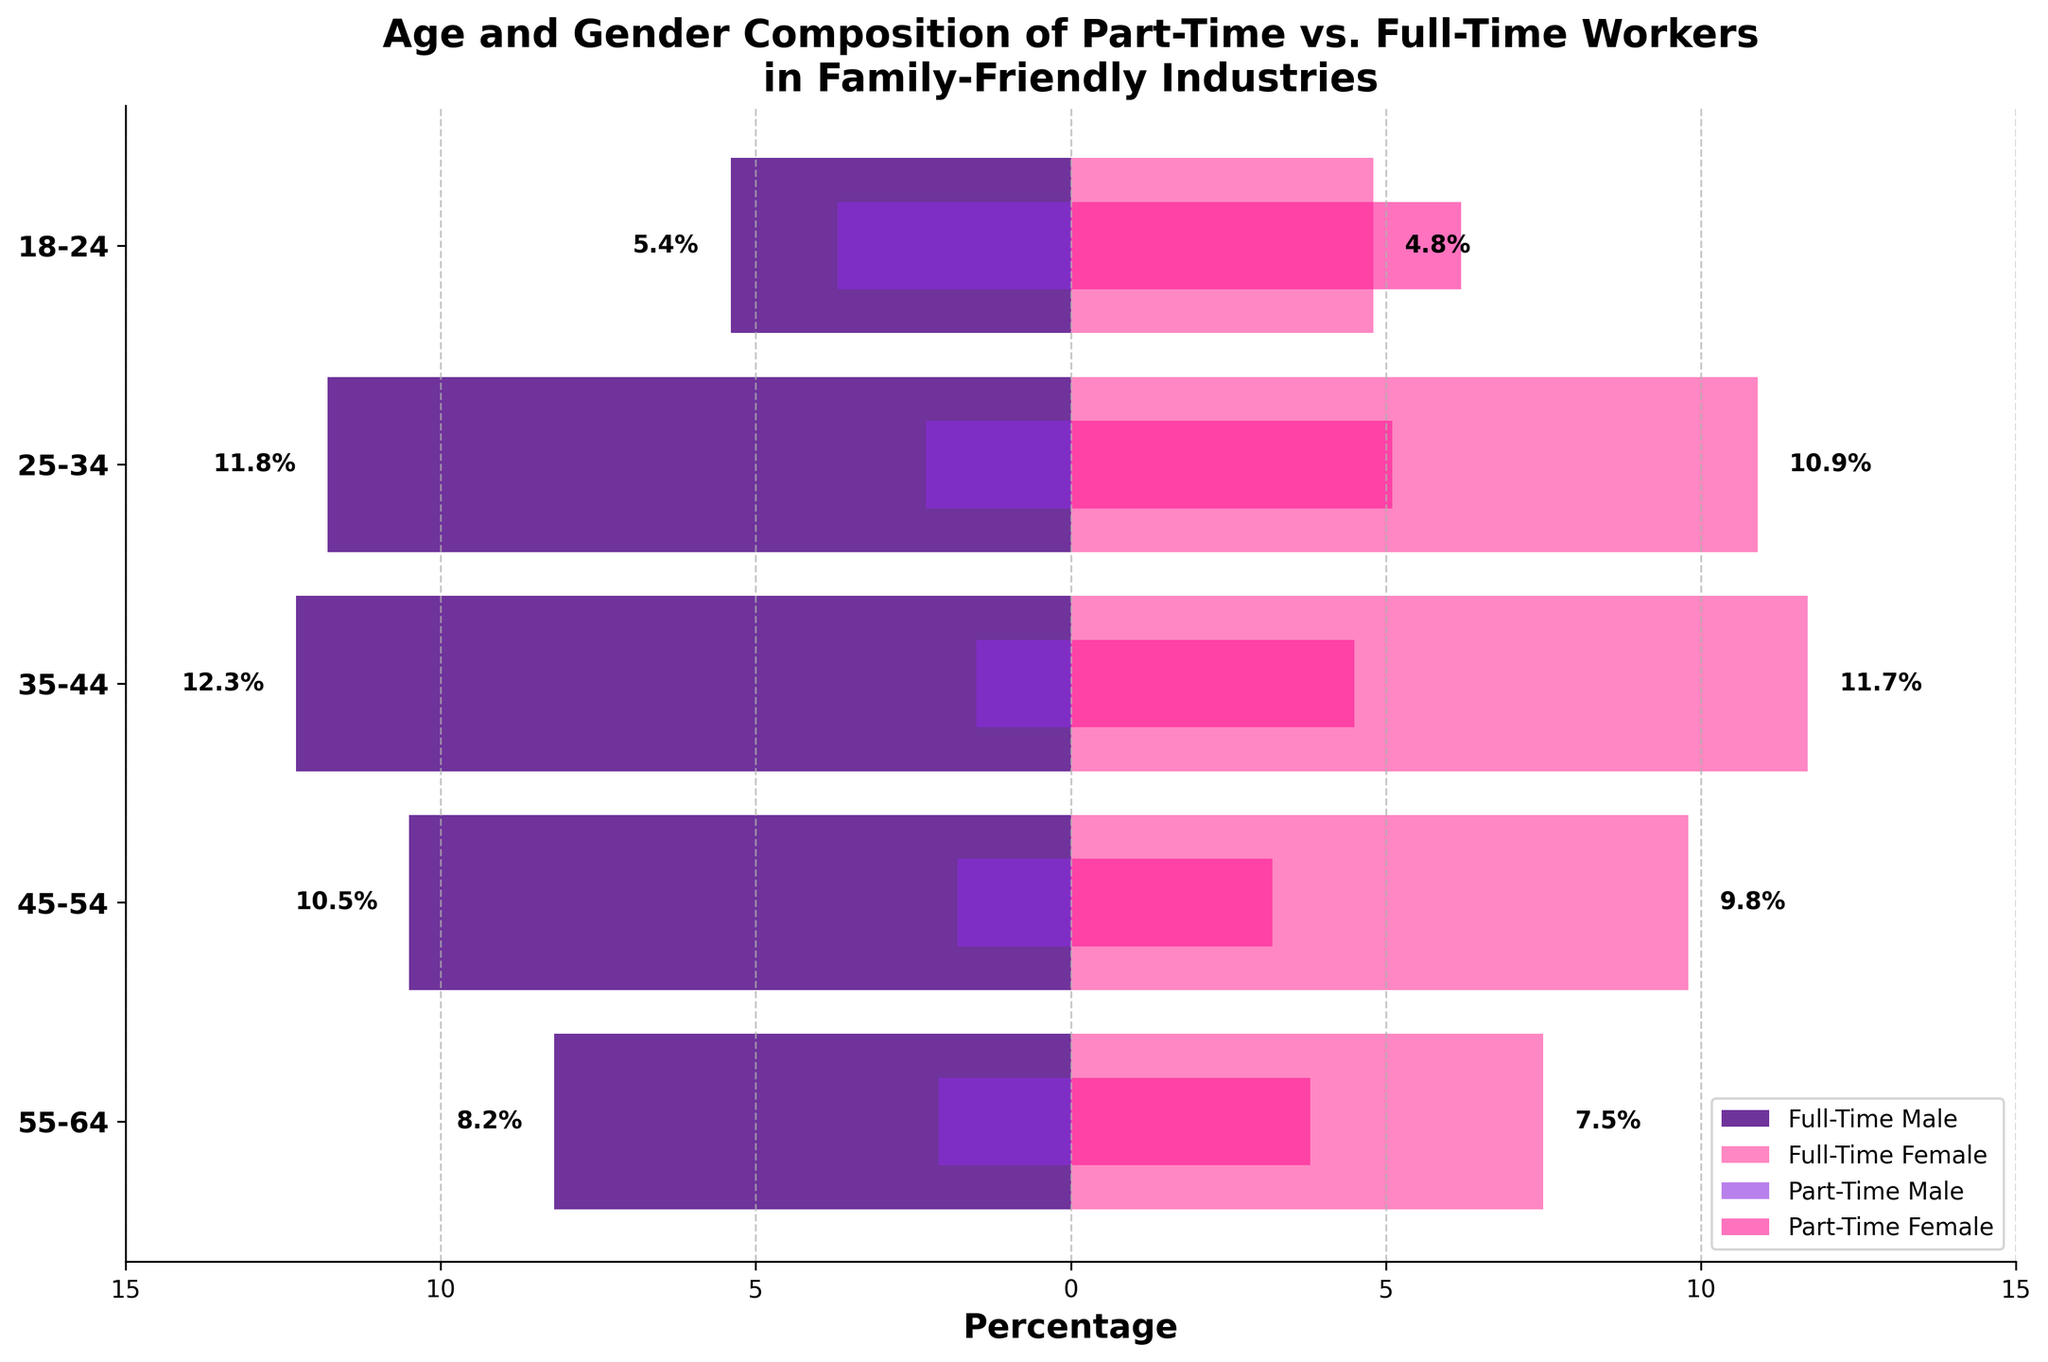What is the title of the figure? The title is located at the top of the figure. It provides a brief description of what the figure represents.
Answer: Age and Gender Composition of Part-Time vs. Full-Time Workers in Family-Friendly Industries Which age group has the highest percentage of full-time male workers? To determine this, look for the longest bar on the negative side of the x-axis within the 'Full-Time Male' section, then refer to the corresponding age group on the y-axis.
Answer: 35-44 In the age group 25-34, which gender has more part-time workers? Compare the lengths of the bars for 'Part-Time Male' and 'Part-Time Female' within the 25-34 age group. The longer bar represents the gender with more part-time workers.
Answer: Female How does the percentage of part-time female workers in the 18-24 age group compare to full-time male workers in the same age group? Look at the lengths of the bars for 'Part-Time Female' and 'Full-Time Male' within the 18-24 age group. The 'Part-Time Female' bar is longer.
Answer: Part-time female workers have a higher percentage What is the sum of full-time male and female workers in the 45-54 age group? Add the percentages from the 'Full-Time Male' and 'Full-Time Female' bars within the 45-54 age group. 10.5% (male) + 9.8% (female) = 20.3%.
Answer: 20.3% What is the percentage difference between part-time male and female workers in the 35-44 age group? Subtract the percentage of 'Part-Time Male' workers from 'Part-Time Female' workers in the 35-44 age group. 4.5% (female) - 1.5% (male) = 3.0%.
Answer: 3.0% Which gender has the lowest full-time worker percentage in the 55-64 age group? Compare the lengths of the bars for 'Full-Time Male' and 'Full-Time Female' within the 55-64 age group. The shorter bar represents the lower percentage.
Answer: Female Which age group has the most balanced percentage of full-time male vs. female workers? Identify the age group where the 'Full-Time Male' and 'Full-Time Female' bars are closest in length.
Answer: 55-64 What is the overall trend in part-time female workers as age decreases? Observe the lengths of the bars for 'Part-Time Female' across different age groups from 55-64 to 18-24. As age decreases, the percentage of part-time female workers generally increases.
Answer: Increasing How much higher is the percentage of part-time female workers compared to part-time male workers in the 18-24 age group? Subtract the percentage of 'Part-Time Male' workers from 'Part-Time Female' workers in the 18-24 age group. 6.2% (female) - 3.7% (male) = 2.5%.
Answer: 2.5% 